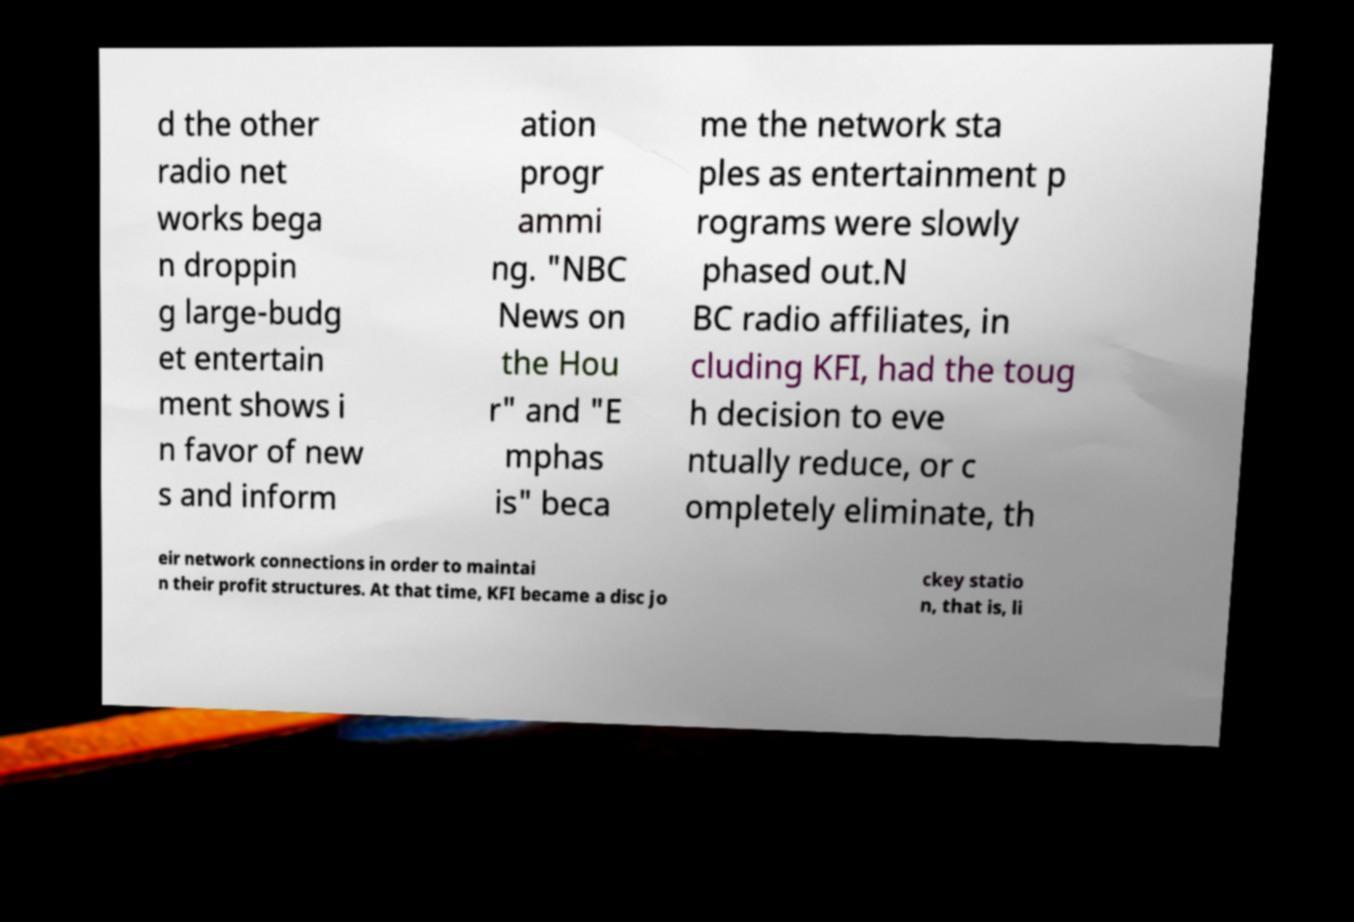Can you read and provide the text displayed in the image?This photo seems to have some interesting text. Can you extract and type it out for me? d the other radio net works bega n droppin g large-budg et entertain ment shows i n favor of new s and inform ation progr ammi ng. "NBC News on the Hou r" and "E mphas is" beca me the network sta ples as entertainment p rograms were slowly phased out.N BC radio affiliates, in cluding KFI, had the toug h decision to eve ntually reduce, or c ompletely eliminate, th eir network connections in order to maintai n their profit structures. At that time, KFI became a disc jo ckey statio n, that is, li 